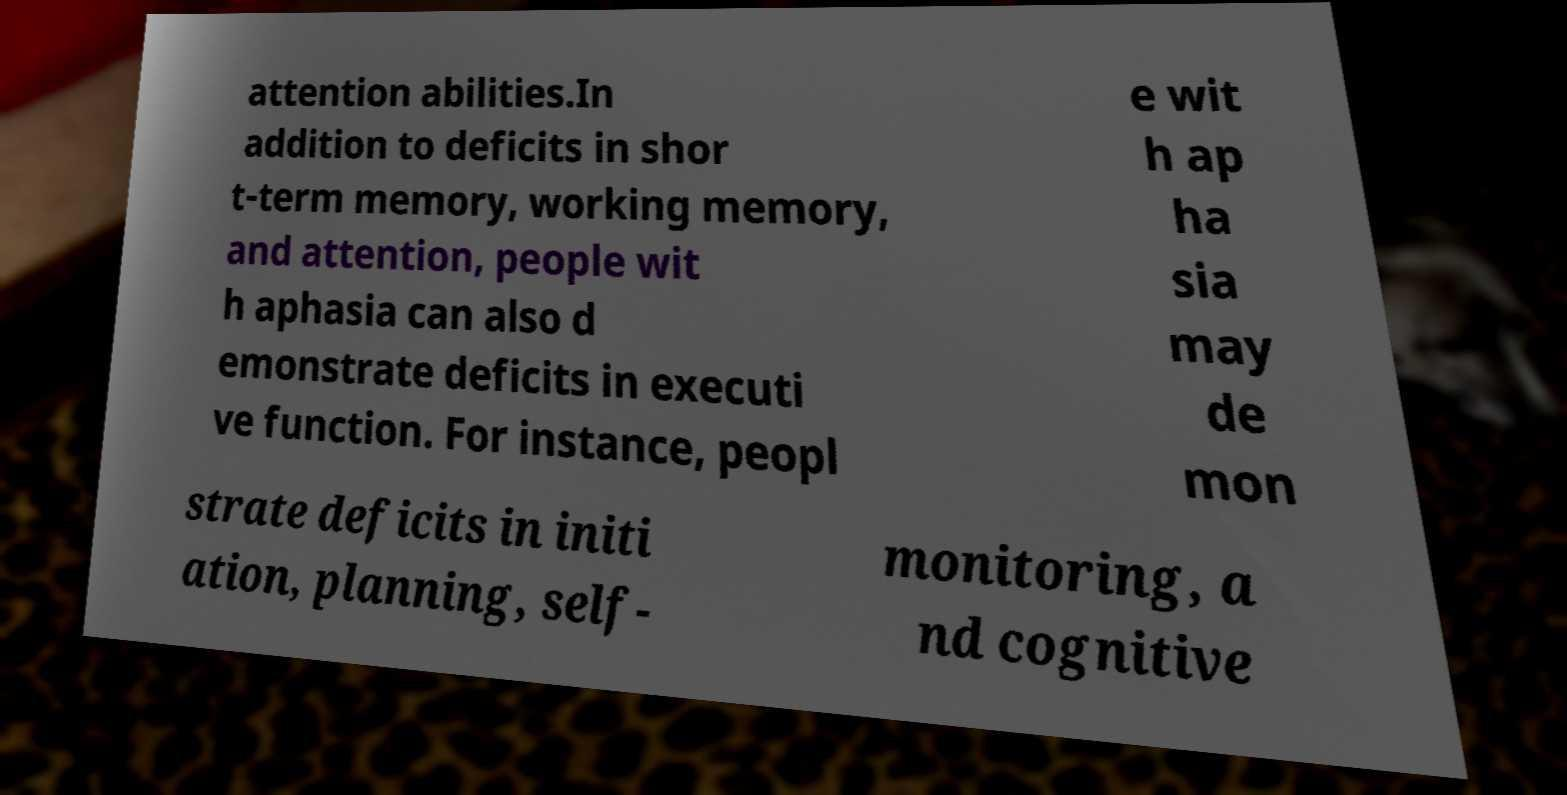Could you extract and type out the text from this image? attention abilities.In addition to deficits in shor t-term memory, working memory, and attention, people wit h aphasia can also d emonstrate deficits in executi ve function. For instance, peopl e wit h ap ha sia may de mon strate deficits in initi ation, planning, self- monitoring, a nd cognitive 